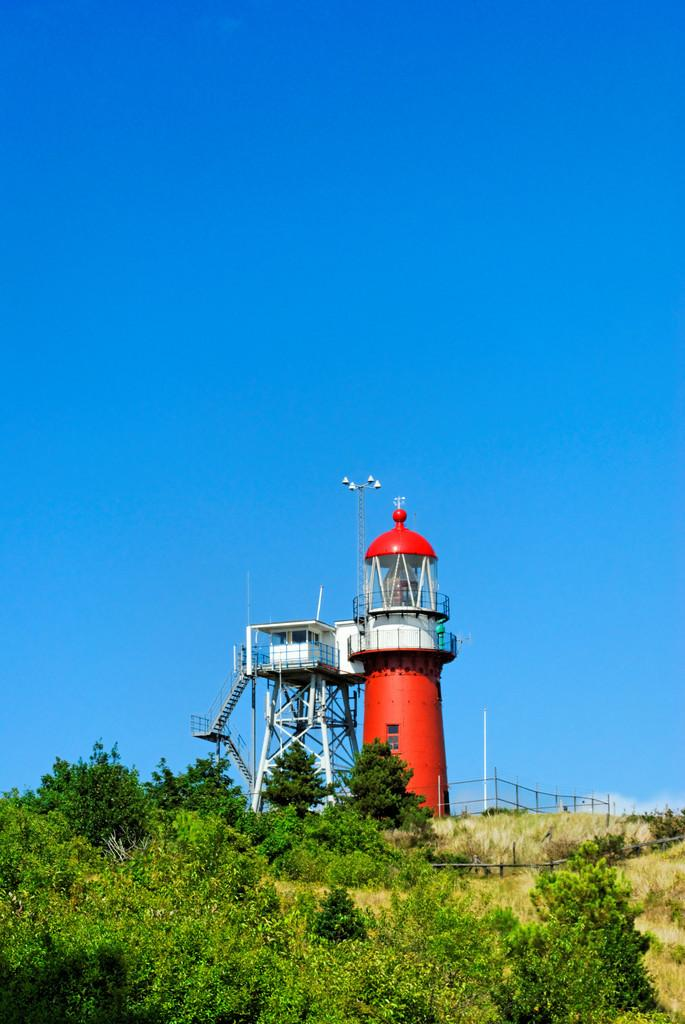What is the main feature in the center of the image? The center of the image contains the sky. What type of vegetation can be seen in the image? Trees are present in the image. What structures are visible in the image? There are fences, a watching tower with steps, and a lighthouse in the image. What might be used for supporting or guiding in the image? Poles are visible in the image. How many girls are playing with a rake in the image? There are no girls or rakes present in the image. 